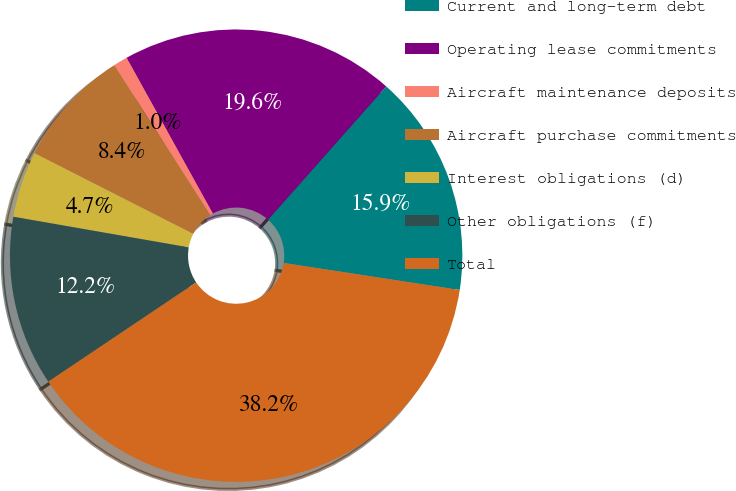<chart> <loc_0><loc_0><loc_500><loc_500><pie_chart><fcel>Current and long-term debt<fcel>Operating lease commitments<fcel>Aircraft maintenance deposits<fcel>Aircraft purchase commitments<fcel>Interest obligations (d)<fcel>Other obligations (f)<fcel>Total<nl><fcel>15.88%<fcel>19.59%<fcel>1.02%<fcel>8.45%<fcel>4.73%<fcel>12.16%<fcel>38.17%<nl></chart> 